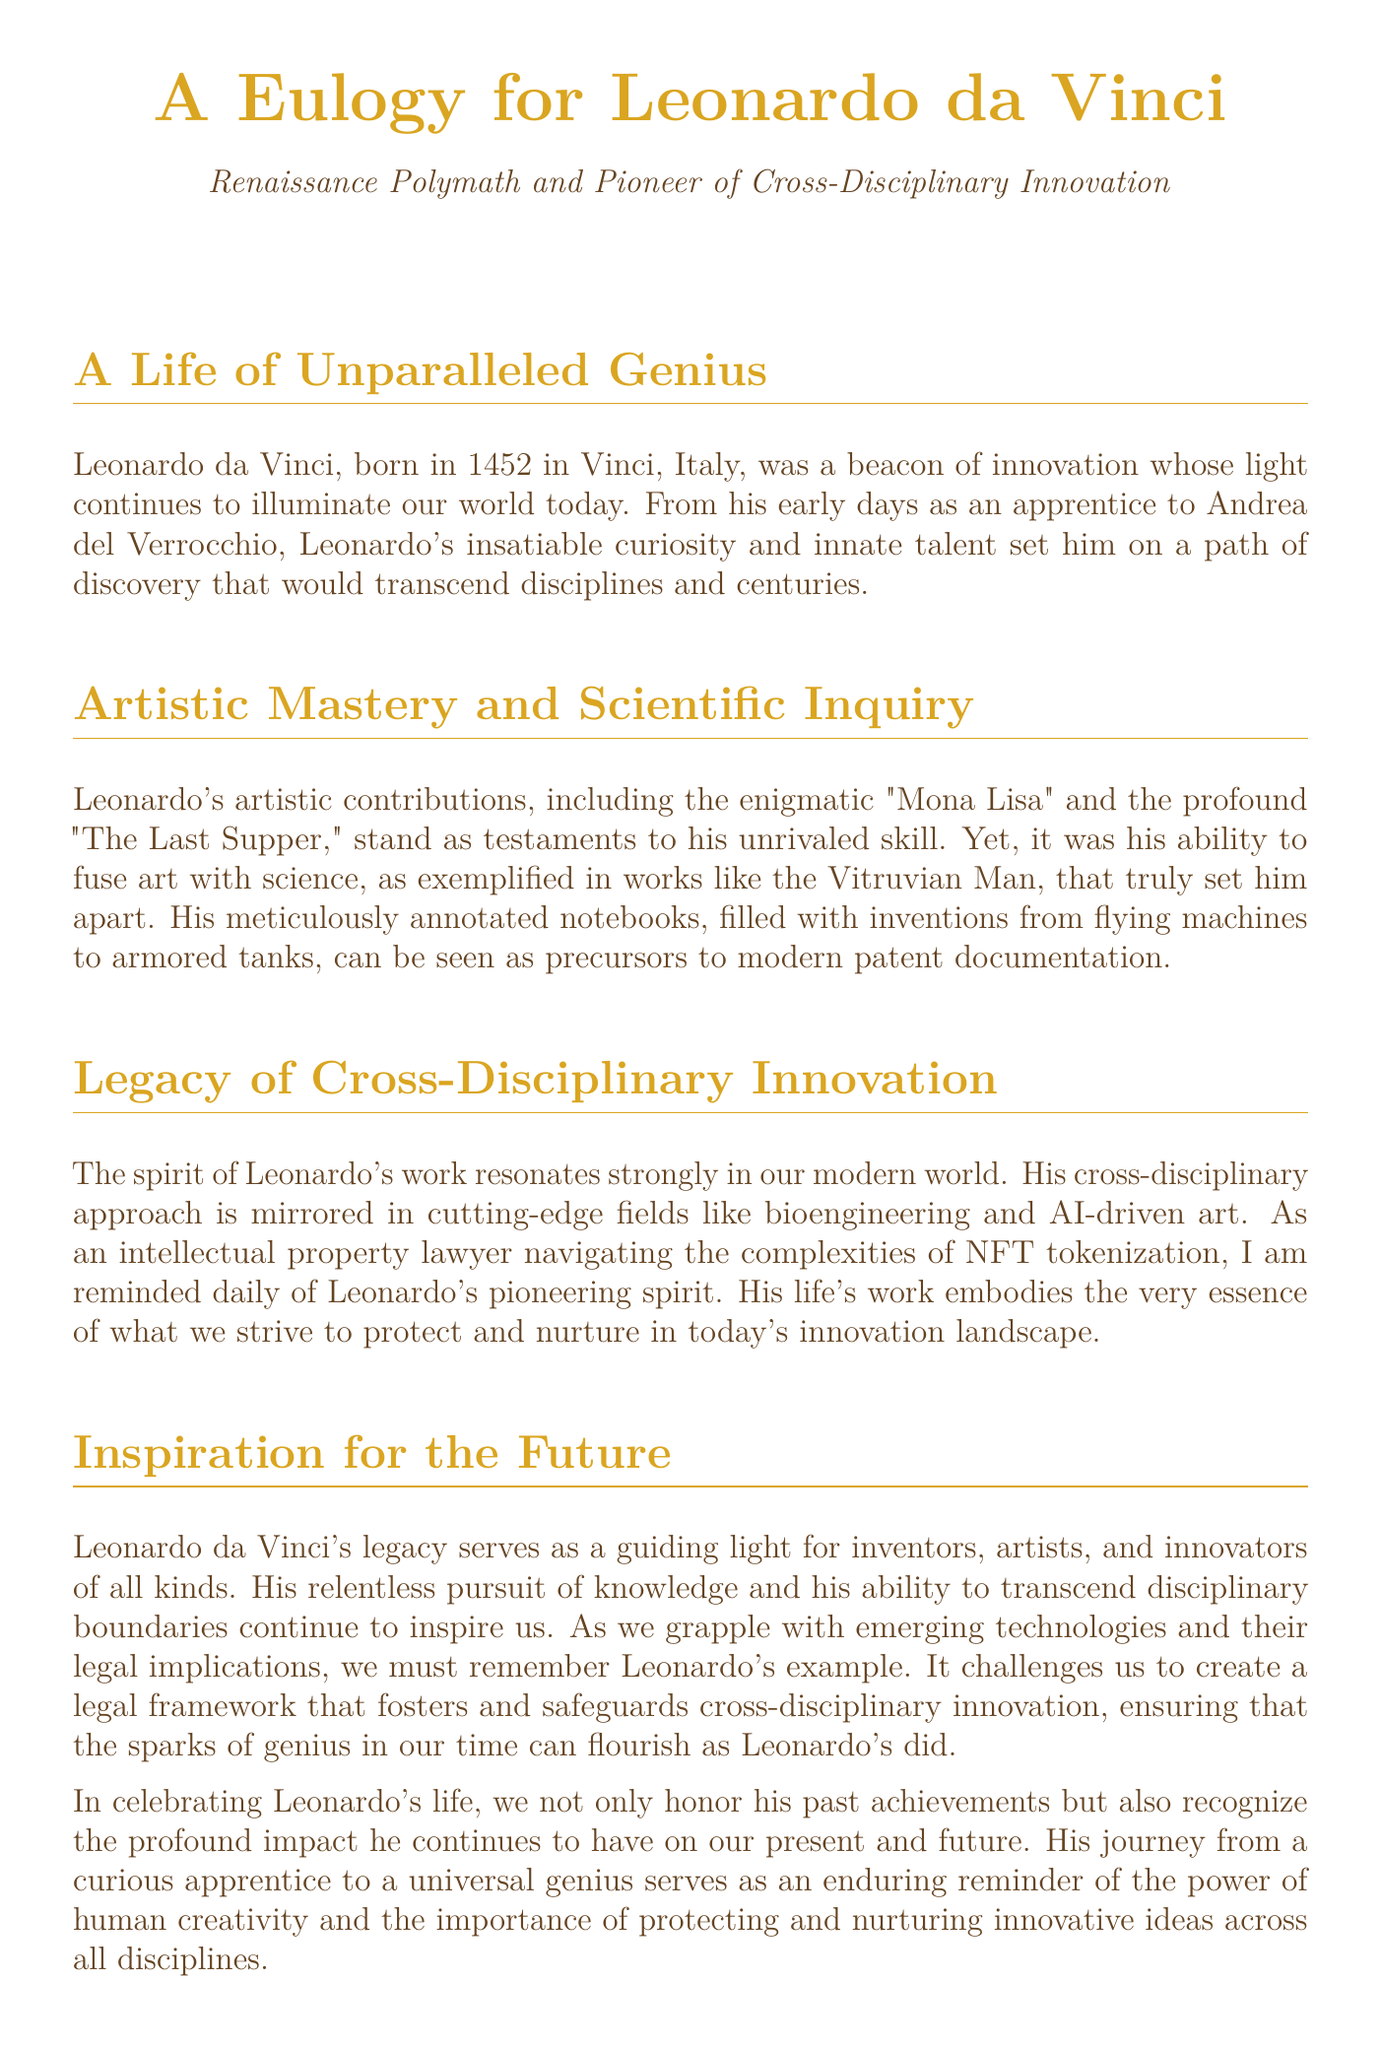What year was Leonardo da Vinci born? The document states that Leonardo da Vinci was born in 1452.
Answer: 1452 What notable painting is mentioned in the eulogy? The eulogy highlights Leonardo's painting "Mona Lisa" as a testament to his artistic skill.
Answer: Mona Lisa What innovative concept does Leonardo's work in notebooks resemble? The text describes Leonardo's notebooks as precursors to modern patent documentation.
Answer: patent documentation Which two cutting-edge fields reflect Leonardo's cross-disciplinary approach? The eulogy mentions bioengineering and AI-driven art as fields mirroring Leonardo's innovative spirit.
Answer: bioengineering and AI-driven art What does Leonardo's legacy inspire inventors and innovators to pursue? The document suggests that Leonardo's legacy inspires a relentless pursuit of knowledge across disciplines.
Answer: knowledge How is Leonardo's approach to innovation relevant to NFT tokenization? The eulogy connects Leonardo's pioneering spirit with the legal framework needed for NFT tokenization.
Answer: pioneering spirit What artistic work exemplifies the combination of art and science? The text cites the "Vitruvian Man" as a prime example of Leonardo's fusion of art and science.
Answer: Vitruvian Man What role does the eulogy suggest for legal frameworks today? The document implies that we must create legal frameworks that foster cross-disciplinary innovation.
Answer: foster cross-disciplinary innovation 